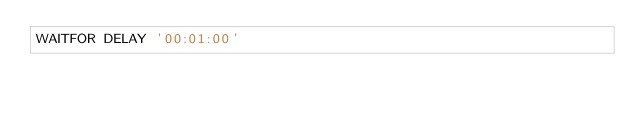<code> <loc_0><loc_0><loc_500><loc_500><_SQL_>WAITFOR DELAY '00:01:00'</code> 